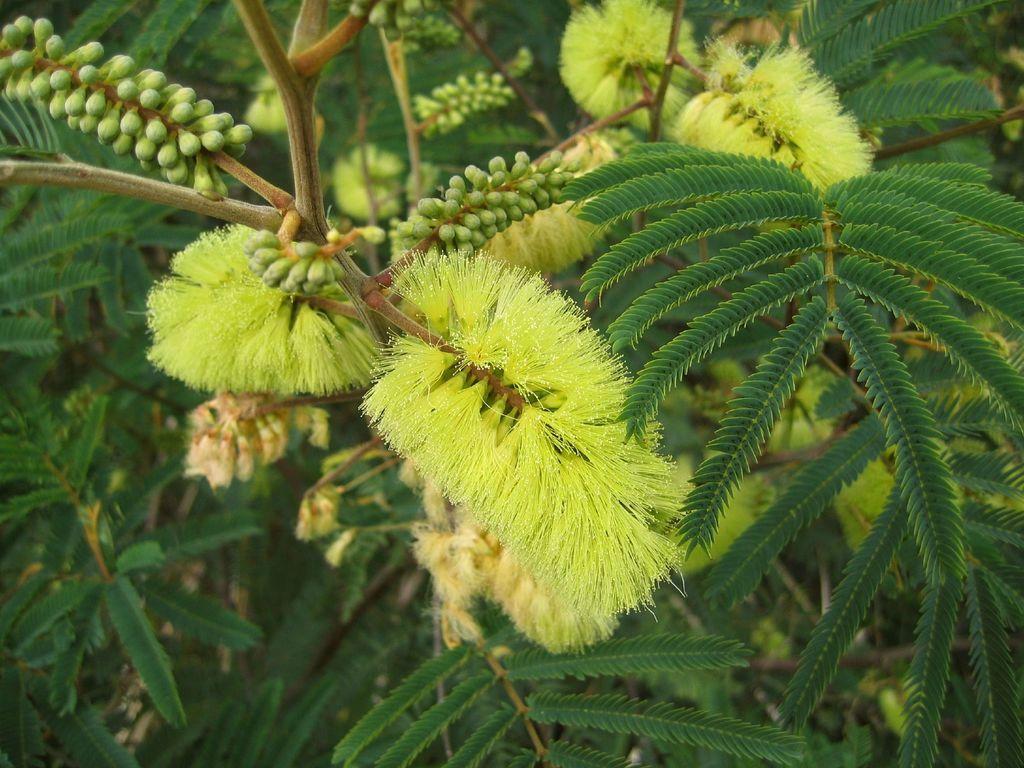In one or two sentences, can you explain what this image depicts? This picture containing a plant which has flowers and buds of the flower. These flowers are in green color. 